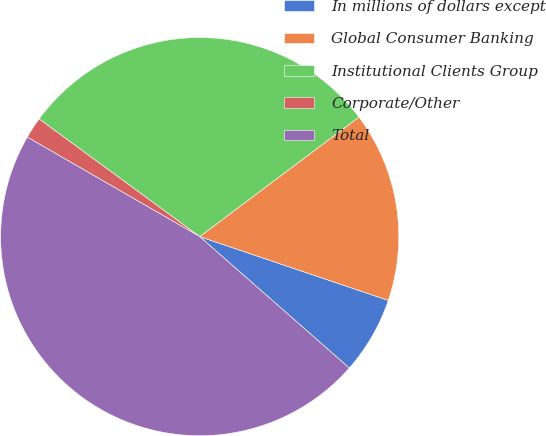Convert chart to OTSL. <chart><loc_0><loc_0><loc_500><loc_500><pie_chart><fcel>In millions of dollars except<fcel>Global Consumer Banking<fcel>Institutional Clients Group<fcel>Corporate/Other<fcel>Total<nl><fcel>6.28%<fcel>15.44%<fcel>29.69%<fcel>1.73%<fcel>46.86%<nl></chart> 